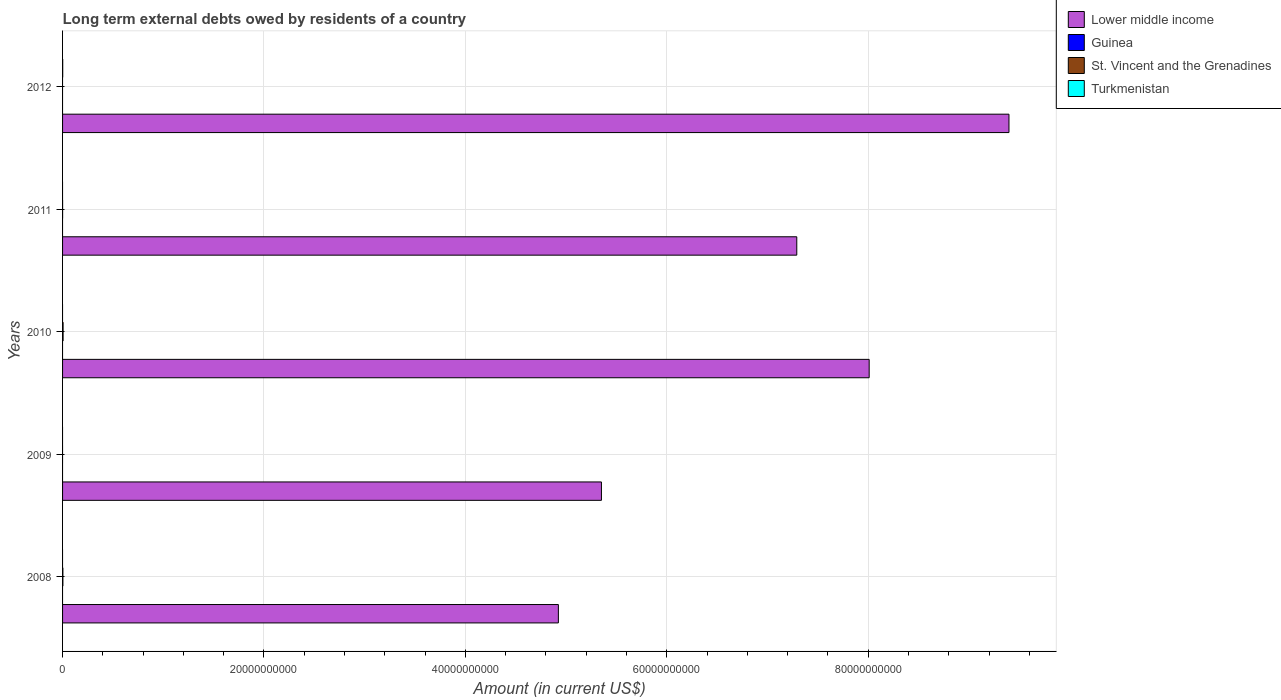Are the number of bars per tick equal to the number of legend labels?
Give a very brief answer. No. Are the number of bars on each tick of the Y-axis equal?
Provide a short and direct response. No. How many bars are there on the 2nd tick from the top?
Your response must be concise. 2. How many bars are there on the 4th tick from the bottom?
Offer a terse response. 2. What is the label of the 2nd group of bars from the top?
Provide a succinct answer. 2011. What is the amount of long-term external debts owed by residents in St. Vincent and the Grenadines in 2010?
Make the answer very short. 5.17e+07. Across all years, what is the maximum amount of long-term external debts owed by residents in Turkmenistan?
Give a very brief answer. 1.36e+07. In which year was the amount of long-term external debts owed by residents in Turkmenistan maximum?
Make the answer very short. 2012. What is the total amount of long-term external debts owed by residents in Lower middle income in the graph?
Provide a succinct answer. 3.50e+11. What is the difference between the amount of long-term external debts owed by residents in Lower middle income in 2010 and that in 2011?
Your answer should be very brief. 7.19e+09. What is the difference between the amount of long-term external debts owed by residents in St. Vincent and the Grenadines in 2010 and the amount of long-term external debts owed by residents in Guinea in 2009?
Provide a short and direct response. 5.17e+07. What is the average amount of long-term external debts owed by residents in Lower middle income per year?
Make the answer very short. 6.99e+1. In the year 2011, what is the difference between the amount of long-term external debts owed by residents in Lower middle income and amount of long-term external debts owed by residents in St. Vincent and the Grenadines?
Your answer should be compact. 7.29e+1. What is the ratio of the amount of long-term external debts owed by residents in St. Vincent and the Grenadines in 2008 to that in 2011?
Keep it short and to the point. 10.6. What is the difference between the highest and the second highest amount of long-term external debts owed by residents in St. Vincent and the Grenadines?
Give a very brief answer. 1.94e+07. What is the difference between the highest and the lowest amount of long-term external debts owed by residents in Lower middle income?
Provide a succinct answer. 4.47e+1. In how many years, is the amount of long-term external debts owed by residents in St. Vincent and the Grenadines greater than the average amount of long-term external debts owed by residents in St. Vincent and the Grenadines taken over all years?
Offer a very short reply. 2. Is the sum of the amount of long-term external debts owed by residents in Lower middle income in 2009 and 2012 greater than the maximum amount of long-term external debts owed by residents in St. Vincent and the Grenadines across all years?
Offer a terse response. Yes. How many bars are there?
Make the answer very short. 9. How many years are there in the graph?
Your answer should be very brief. 5. What is the difference between two consecutive major ticks on the X-axis?
Ensure brevity in your answer.  2.00e+1. Are the values on the major ticks of X-axis written in scientific E-notation?
Offer a very short reply. No. Does the graph contain any zero values?
Your response must be concise. Yes. Does the graph contain grids?
Give a very brief answer. Yes. What is the title of the graph?
Your answer should be compact. Long term external debts owed by residents of a country. Does "Jordan" appear as one of the legend labels in the graph?
Offer a terse response. No. What is the Amount (in current US$) in Lower middle income in 2008?
Keep it short and to the point. 4.92e+1. What is the Amount (in current US$) of St. Vincent and the Grenadines in 2008?
Offer a terse response. 3.23e+07. What is the Amount (in current US$) of Turkmenistan in 2008?
Ensure brevity in your answer.  0. What is the Amount (in current US$) in Lower middle income in 2009?
Offer a very short reply. 5.35e+1. What is the Amount (in current US$) of St. Vincent and the Grenadines in 2009?
Your answer should be very brief. 0. What is the Amount (in current US$) in Lower middle income in 2010?
Keep it short and to the point. 8.01e+1. What is the Amount (in current US$) of Guinea in 2010?
Provide a succinct answer. 0. What is the Amount (in current US$) of St. Vincent and the Grenadines in 2010?
Offer a very short reply. 5.17e+07. What is the Amount (in current US$) of Turkmenistan in 2010?
Your answer should be very brief. 0. What is the Amount (in current US$) in Lower middle income in 2011?
Provide a short and direct response. 7.29e+1. What is the Amount (in current US$) in Guinea in 2011?
Offer a terse response. 0. What is the Amount (in current US$) of St. Vincent and the Grenadines in 2011?
Offer a very short reply. 3.04e+06. What is the Amount (in current US$) of Lower middle income in 2012?
Provide a short and direct response. 9.40e+1. What is the Amount (in current US$) of Turkmenistan in 2012?
Offer a terse response. 1.36e+07. Across all years, what is the maximum Amount (in current US$) in Lower middle income?
Your response must be concise. 9.40e+1. Across all years, what is the maximum Amount (in current US$) in St. Vincent and the Grenadines?
Make the answer very short. 5.17e+07. Across all years, what is the maximum Amount (in current US$) in Turkmenistan?
Offer a very short reply. 1.36e+07. Across all years, what is the minimum Amount (in current US$) in Lower middle income?
Give a very brief answer. 4.92e+1. Across all years, what is the minimum Amount (in current US$) of Turkmenistan?
Offer a terse response. 0. What is the total Amount (in current US$) of Lower middle income in the graph?
Your answer should be compact. 3.50e+11. What is the total Amount (in current US$) of Guinea in the graph?
Provide a short and direct response. 0. What is the total Amount (in current US$) of St. Vincent and the Grenadines in the graph?
Provide a succinct answer. 8.70e+07. What is the total Amount (in current US$) of Turkmenistan in the graph?
Offer a very short reply. 1.36e+07. What is the difference between the Amount (in current US$) of Lower middle income in 2008 and that in 2009?
Your answer should be compact. -4.28e+09. What is the difference between the Amount (in current US$) of Lower middle income in 2008 and that in 2010?
Give a very brief answer. -3.09e+1. What is the difference between the Amount (in current US$) of St. Vincent and the Grenadines in 2008 and that in 2010?
Offer a terse response. -1.94e+07. What is the difference between the Amount (in current US$) in Lower middle income in 2008 and that in 2011?
Offer a very short reply. -2.37e+1. What is the difference between the Amount (in current US$) in St. Vincent and the Grenadines in 2008 and that in 2011?
Your response must be concise. 2.92e+07. What is the difference between the Amount (in current US$) in Lower middle income in 2008 and that in 2012?
Keep it short and to the point. -4.47e+1. What is the difference between the Amount (in current US$) in Lower middle income in 2009 and that in 2010?
Keep it short and to the point. -2.66e+1. What is the difference between the Amount (in current US$) in Lower middle income in 2009 and that in 2011?
Ensure brevity in your answer.  -1.94e+1. What is the difference between the Amount (in current US$) in Lower middle income in 2009 and that in 2012?
Your response must be concise. -4.05e+1. What is the difference between the Amount (in current US$) in Lower middle income in 2010 and that in 2011?
Your answer should be very brief. 7.19e+09. What is the difference between the Amount (in current US$) of St. Vincent and the Grenadines in 2010 and that in 2011?
Provide a succinct answer. 4.86e+07. What is the difference between the Amount (in current US$) of Lower middle income in 2010 and that in 2012?
Offer a terse response. -1.39e+1. What is the difference between the Amount (in current US$) in Lower middle income in 2011 and that in 2012?
Provide a succinct answer. -2.11e+1. What is the difference between the Amount (in current US$) of Lower middle income in 2008 and the Amount (in current US$) of St. Vincent and the Grenadines in 2010?
Your answer should be compact. 4.92e+1. What is the difference between the Amount (in current US$) of Lower middle income in 2008 and the Amount (in current US$) of St. Vincent and the Grenadines in 2011?
Provide a short and direct response. 4.92e+1. What is the difference between the Amount (in current US$) in Lower middle income in 2008 and the Amount (in current US$) in Turkmenistan in 2012?
Offer a very short reply. 4.92e+1. What is the difference between the Amount (in current US$) of St. Vincent and the Grenadines in 2008 and the Amount (in current US$) of Turkmenistan in 2012?
Ensure brevity in your answer.  1.86e+07. What is the difference between the Amount (in current US$) of Lower middle income in 2009 and the Amount (in current US$) of St. Vincent and the Grenadines in 2010?
Provide a succinct answer. 5.35e+1. What is the difference between the Amount (in current US$) in Lower middle income in 2009 and the Amount (in current US$) in St. Vincent and the Grenadines in 2011?
Ensure brevity in your answer.  5.35e+1. What is the difference between the Amount (in current US$) of Lower middle income in 2009 and the Amount (in current US$) of Turkmenistan in 2012?
Keep it short and to the point. 5.35e+1. What is the difference between the Amount (in current US$) in Lower middle income in 2010 and the Amount (in current US$) in St. Vincent and the Grenadines in 2011?
Keep it short and to the point. 8.01e+1. What is the difference between the Amount (in current US$) in Lower middle income in 2010 and the Amount (in current US$) in Turkmenistan in 2012?
Your response must be concise. 8.01e+1. What is the difference between the Amount (in current US$) in St. Vincent and the Grenadines in 2010 and the Amount (in current US$) in Turkmenistan in 2012?
Give a very brief answer. 3.80e+07. What is the difference between the Amount (in current US$) in Lower middle income in 2011 and the Amount (in current US$) in Turkmenistan in 2012?
Keep it short and to the point. 7.29e+1. What is the difference between the Amount (in current US$) of St. Vincent and the Grenadines in 2011 and the Amount (in current US$) of Turkmenistan in 2012?
Offer a terse response. -1.06e+07. What is the average Amount (in current US$) in Lower middle income per year?
Give a very brief answer. 6.99e+1. What is the average Amount (in current US$) of St. Vincent and the Grenadines per year?
Your answer should be very brief. 1.74e+07. What is the average Amount (in current US$) of Turkmenistan per year?
Your answer should be very brief. 2.73e+06. In the year 2008, what is the difference between the Amount (in current US$) of Lower middle income and Amount (in current US$) of St. Vincent and the Grenadines?
Provide a succinct answer. 4.92e+1. In the year 2010, what is the difference between the Amount (in current US$) in Lower middle income and Amount (in current US$) in St. Vincent and the Grenadines?
Your answer should be compact. 8.00e+1. In the year 2011, what is the difference between the Amount (in current US$) of Lower middle income and Amount (in current US$) of St. Vincent and the Grenadines?
Provide a succinct answer. 7.29e+1. In the year 2012, what is the difference between the Amount (in current US$) in Lower middle income and Amount (in current US$) in Turkmenistan?
Your answer should be very brief. 9.40e+1. What is the ratio of the Amount (in current US$) in Lower middle income in 2008 to that in 2009?
Your answer should be compact. 0.92. What is the ratio of the Amount (in current US$) of Lower middle income in 2008 to that in 2010?
Make the answer very short. 0.61. What is the ratio of the Amount (in current US$) of St. Vincent and the Grenadines in 2008 to that in 2010?
Give a very brief answer. 0.62. What is the ratio of the Amount (in current US$) in Lower middle income in 2008 to that in 2011?
Offer a very short reply. 0.68. What is the ratio of the Amount (in current US$) in St. Vincent and the Grenadines in 2008 to that in 2011?
Your response must be concise. 10.6. What is the ratio of the Amount (in current US$) in Lower middle income in 2008 to that in 2012?
Provide a succinct answer. 0.52. What is the ratio of the Amount (in current US$) in Lower middle income in 2009 to that in 2010?
Offer a terse response. 0.67. What is the ratio of the Amount (in current US$) of Lower middle income in 2009 to that in 2011?
Offer a very short reply. 0.73. What is the ratio of the Amount (in current US$) of Lower middle income in 2009 to that in 2012?
Keep it short and to the point. 0.57. What is the ratio of the Amount (in current US$) in Lower middle income in 2010 to that in 2011?
Keep it short and to the point. 1.1. What is the ratio of the Amount (in current US$) in St. Vincent and the Grenadines in 2010 to that in 2011?
Provide a succinct answer. 16.97. What is the ratio of the Amount (in current US$) of Lower middle income in 2010 to that in 2012?
Make the answer very short. 0.85. What is the ratio of the Amount (in current US$) of Lower middle income in 2011 to that in 2012?
Make the answer very short. 0.78. What is the difference between the highest and the second highest Amount (in current US$) of Lower middle income?
Keep it short and to the point. 1.39e+1. What is the difference between the highest and the second highest Amount (in current US$) of St. Vincent and the Grenadines?
Your answer should be compact. 1.94e+07. What is the difference between the highest and the lowest Amount (in current US$) in Lower middle income?
Give a very brief answer. 4.47e+1. What is the difference between the highest and the lowest Amount (in current US$) in St. Vincent and the Grenadines?
Your response must be concise. 5.17e+07. What is the difference between the highest and the lowest Amount (in current US$) in Turkmenistan?
Your answer should be very brief. 1.36e+07. 